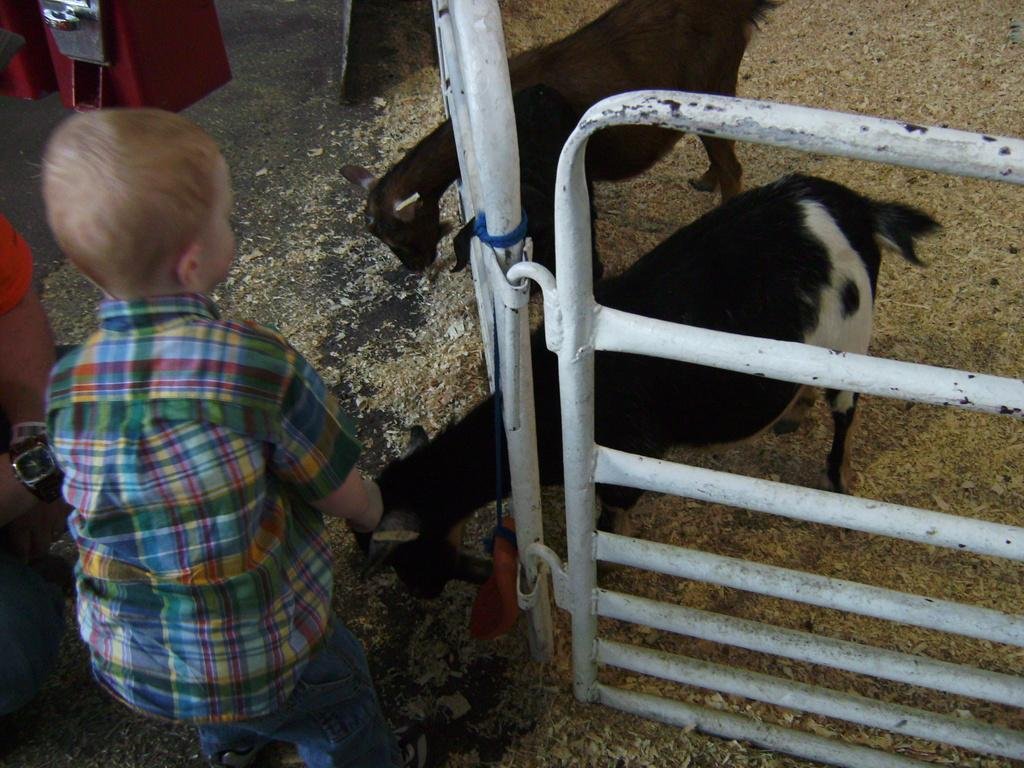Who is the main subject in the image? There is a boy in the image. Where is the boy located in the image? The boy is on the left side of the image. What animals are present in front of the boy? There are two goats in front of the boy. What can be seen on the right side of the image? There is a white color gate on the right side of the image. What type of sail can be seen on the goats in the image? There are no sails present in the image, as the animals are goats and not boats. 